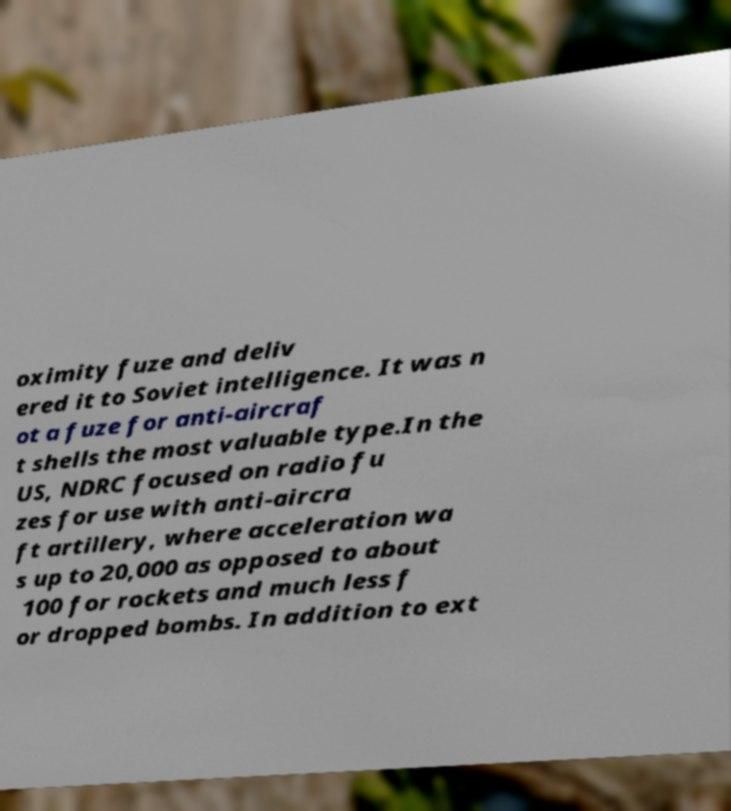Can you accurately transcribe the text from the provided image for me? oximity fuze and deliv ered it to Soviet intelligence. It was n ot a fuze for anti-aircraf t shells the most valuable type.In the US, NDRC focused on radio fu zes for use with anti-aircra ft artillery, where acceleration wa s up to 20,000 as opposed to about 100 for rockets and much less f or dropped bombs. In addition to ext 